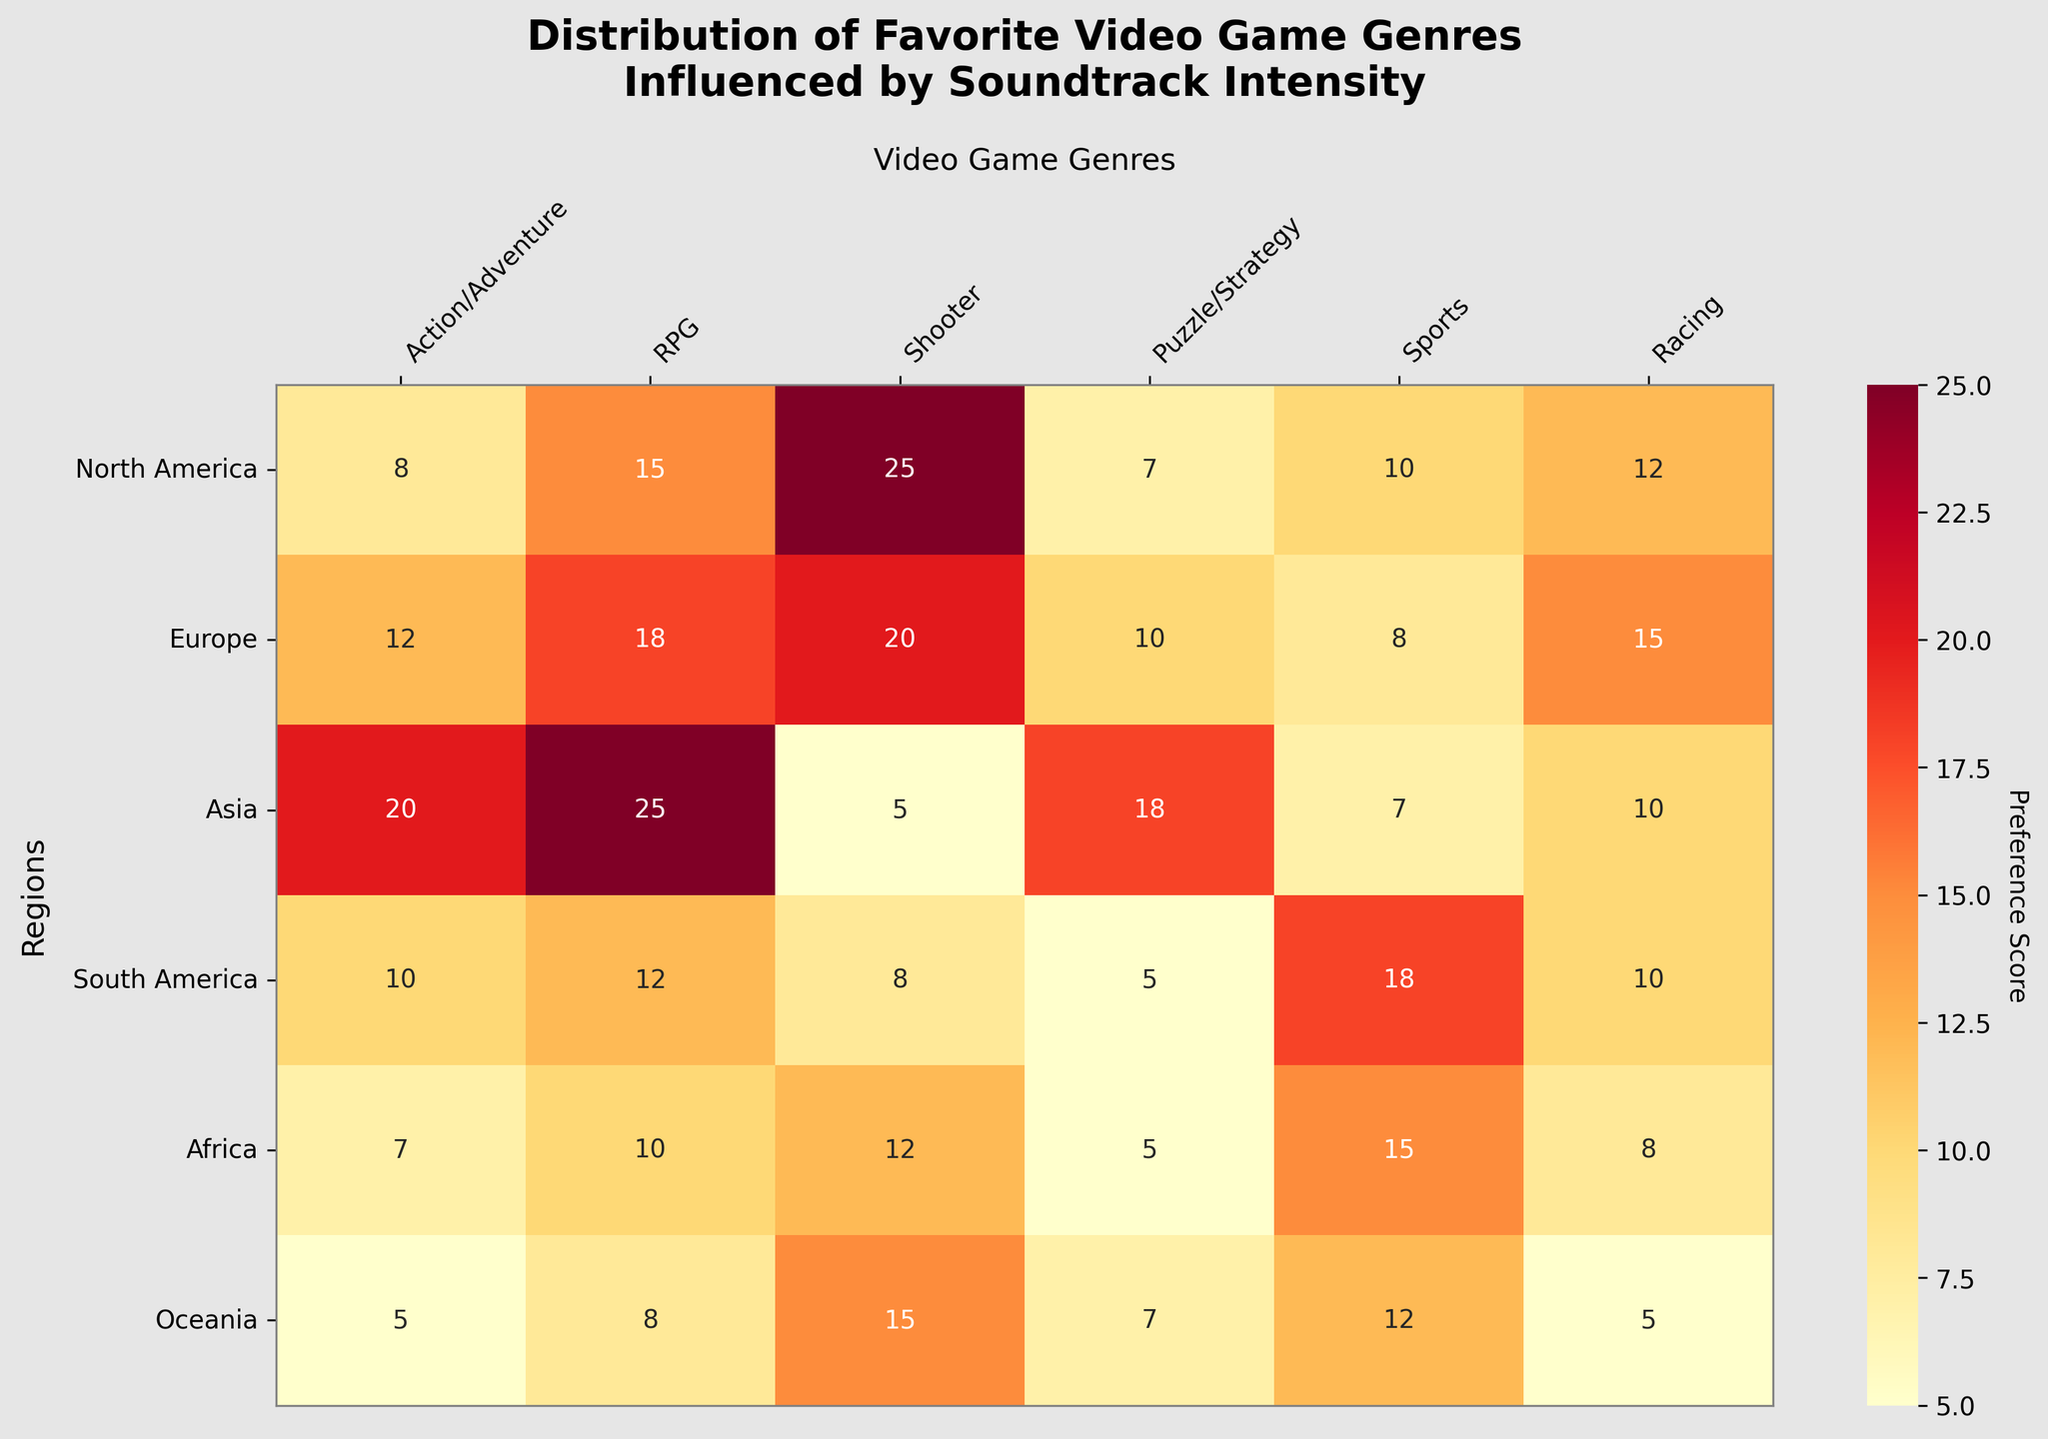What is the title of the plot? The title is located at the top of the plot. It reads: "Distribution of Favorite Video Game Genres Influenced by Soundtrack Intensity".
Answer: Distribution of Favorite Video Game Genres Influenced by Soundtrack Intensity Which region has the highest preference for RPGs? By looking at the RPG column and finding the cell with the highest value, the region with the strongest preference for RPGs is Asia with a score of 25.
Answer: Asia How many regions have a preference score of 10 or higher for Racing games? The 'Racing' column shows North America (12), Europe (15), Asia (10), South America (10), and Africa (8). Four regions (North America, Europe, Asia, and South America) have a score of 10 or higher.
Answer: 4 What is the average preference score for Sports games across all regions? The scores for Sports are 10 (North America), 8 (Europe), 7 (Asia), 18 (South America), 15 (Africa), and 12 (Oceania). Add these scores to get the total: 10 + 8 + 7 + 18 + 15 + 12 = 70. There are 6 regions, so the average is 70 / 6.
Answer: 11.67 Which region has the lowest preference score for Puzzle/Strategy games? Looking at the 'Puzzle/Strategy' column, the lowest score is for South America with a score of 5.
Answer: South America Which genre shows the greatest variation in preference scores across regions? By visually comparing the range of values in each column (genre), 'Shooter' has the widest variety from 5 (Asia) to 25 (North America).
Answer: Shooter What are the preference scores for RPGs in Europe and North America combined? The value for Europe is 18 and North America's value is 15. Adding them, we get 18 + 15 = 33.
Answer: 33 Between Action/Adventure and Puzzle/Strategy, which genre has a higher average preference score across all regions? Calculate average scores: Action/Adventure: (8 + 12 + 20 + 10 + 7 + 5) / 6 = 10.33, Puzzle/Strategy: (7 + 10 + 18 + 5 + 5 + 7) / 6 = 8.67.
Answer: Action/Adventure Which region has the highest overall preference score summed up from all genres? Calculate total scores by summing each row: North America: 77, Europe: 83, Asia: 85, South America: 63, Africa: 57, Oceania: 52. Asia has the highest total score of 85.
Answer: Asia In which regions do we see an equal preference score for Sports and Racing games? Compare the 'Sports' and 'Racing' columns for equal values. South America has equal scores for both genres, which are 10 each.
Answer: South America 